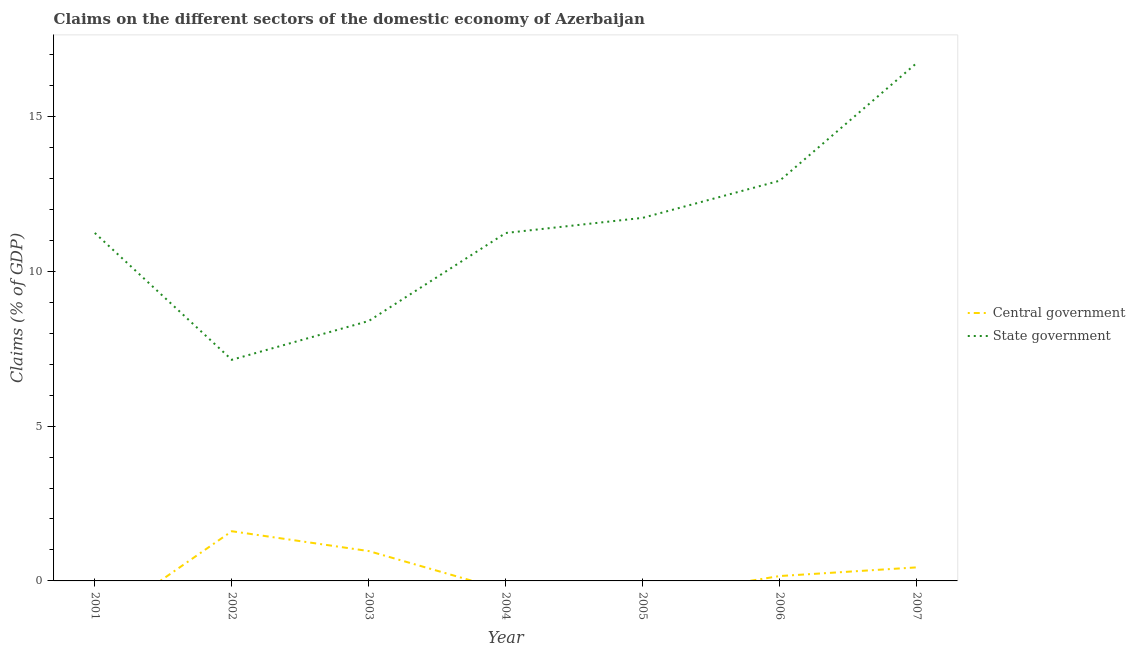How many different coloured lines are there?
Keep it short and to the point. 2. Is the number of lines equal to the number of legend labels?
Your answer should be compact. No. What is the claims on central government in 2001?
Your answer should be very brief. 0. Across all years, what is the maximum claims on state government?
Your answer should be very brief. 16.73. Across all years, what is the minimum claims on central government?
Keep it short and to the point. 0. In which year was the claims on central government maximum?
Give a very brief answer. 2002. What is the total claims on central government in the graph?
Offer a terse response. 3.16. What is the difference between the claims on state government in 2001 and that in 2007?
Ensure brevity in your answer.  -5.49. What is the difference between the claims on state government in 2004 and the claims on central government in 2001?
Your response must be concise. 11.24. What is the average claims on central government per year?
Ensure brevity in your answer.  0.45. In the year 2006, what is the difference between the claims on state government and claims on central government?
Offer a terse response. 12.77. What is the ratio of the claims on state government in 2004 to that in 2006?
Make the answer very short. 0.87. What is the difference between the highest and the second highest claims on state government?
Provide a short and direct response. 3.8. What is the difference between the highest and the lowest claims on central government?
Make the answer very short. 1.6. Is the sum of the claims on state government in 2005 and 2006 greater than the maximum claims on central government across all years?
Give a very brief answer. Yes. Does the claims on state government monotonically increase over the years?
Ensure brevity in your answer.  No. Is the claims on central government strictly less than the claims on state government over the years?
Provide a succinct answer. Yes. How many lines are there?
Provide a short and direct response. 2. What is the difference between two consecutive major ticks on the Y-axis?
Your answer should be very brief. 5. Are the values on the major ticks of Y-axis written in scientific E-notation?
Your answer should be very brief. No. Does the graph contain any zero values?
Provide a short and direct response. Yes. Does the graph contain grids?
Offer a terse response. No. Where does the legend appear in the graph?
Offer a very short reply. Center right. What is the title of the graph?
Give a very brief answer. Claims on the different sectors of the domestic economy of Azerbaijan. Does "Banks" appear as one of the legend labels in the graph?
Provide a succinct answer. No. What is the label or title of the X-axis?
Provide a short and direct response. Year. What is the label or title of the Y-axis?
Your answer should be very brief. Claims (% of GDP). What is the Claims (% of GDP) of Central government in 2001?
Provide a short and direct response. 0. What is the Claims (% of GDP) in State government in 2001?
Offer a terse response. 11.24. What is the Claims (% of GDP) of Central government in 2002?
Give a very brief answer. 1.6. What is the Claims (% of GDP) in State government in 2002?
Give a very brief answer. 7.14. What is the Claims (% of GDP) in Central government in 2003?
Your answer should be compact. 0.96. What is the Claims (% of GDP) in State government in 2003?
Keep it short and to the point. 8.4. What is the Claims (% of GDP) in Central government in 2004?
Your response must be concise. 0. What is the Claims (% of GDP) in State government in 2004?
Give a very brief answer. 11.24. What is the Claims (% of GDP) of State government in 2005?
Make the answer very short. 11.73. What is the Claims (% of GDP) in Central government in 2006?
Give a very brief answer. 0.16. What is the Claims (% of GDP) in State government in 2006?
Make the answer very short. 12.93. What is the Claims (% of GDP) of Central government in 2007?
Provide a succinct answer. 0.44. What is the Claims (% of GDP) of State government in 2007?
Give a very brief answer. 16.73. Across all years, what is the maximum Claims (% of GDP) in Central government?
Offer a very short reply. 1.6. Across all years, what is the maximum Claims (% of GDP) in State government?
Provide a succinct answer. 16.73. Across all years, what is the minimum Claims (% of GDP) in Central government?
Ensure brevity in your answer.  0. Across all years, what is the minimum Claims (% of GDP) of State government?
Your answer should be very brief. 7.14. What is the total Claims (% of GDP) in Central government in the graph?
Offer a very short reply. 3.16. What is the total Claims (% of GDP) in State government in the graph?
Your response must be concise. 79.39. What is the difference between the Claims (% of GDP) in State government in 2001 and that in 2002?
Provide a short and direct response. 4.1. What is the difference between the Claims (% of GDP) in State government in 2001 and that in 2003?
Make the answer very short. 2.84. What is the difference between the Claims (% of GDP) of State government in 2001 and that in 2004?
Provide a short and direct response. 0. What is the difference between the Claims (% of GDP) of State government in 2001 and that in 2005?
Provide a short and direct response. -0.49. What is the difference between the Claims (% of GDP) in State government in 2001 and that in 2006?
Provide a short and direct response. -1.69. What is the difference between the Claims (% of GDP) in State government in 2001 and that in 2007?
Offer a terse response. -5.49. What is the difference between the Claims (% of GDP) in Central government in 2002 and that in 2003?
Your response must be concise. 0.64. What is the difference between the Claims (% of GDP) in State government in 2002 and that in 2003?
Ensure brevity in your answer.  -1.25. What is the difference between the Claims (% of GDP) in State government in 2002 and that in 2004?
Make the answer very short. -4.1. What is the difference between the Claims (% of GDP) of State government in 2002 and that in 2005?
Keep it short and to the point. -4.58. What is the difference between the Claims (% of GDP) of Central government in 2002 and that in 2006?
Ensure brevity in your answer.  1.45. What is the difference between the Claims (% of GDP) in State government in 2002 and that in 2006?
Your answer should be very brief. -5.78. What is the difference between the Claims (% of GDP) in Central government in 2002 and that in 2007?
Keep it short and to the point. 1.17. What is the difference between the Claims (% of GDP) of State government in 2002 and that in 2007?
Give a very brief answer. -9.58. What is the difference between the Claims (% of GDP) in State government in 2003 and that in 2004?
Your answer should be very brief. -2.84. What is the difference between the Claims (% of GDP) of State government in 2003 and that in 2005?
Your answer should be very brief. -3.33. What is the difference between the Claims (% of GDP) of Central government in 2003 and that in 2006?
Offer a very short reply. 0.81. What is the difference between the Claims (% of GDP) in State government in 2003 and that in 2006?
Offer a very short reply. -4.53. What is the difference between the Claims (% of GDP) of Central government in 2003 and that in 2007?
Your answer should be compact. 0.53. What is the difference between the Claims (% of GDP) of State government in 2003 and that in 2007?
Ensure brevity in your answer.  -8.33. What is the difference between the Claims (% of GDP) of State government in 2004 and that in 2005?
Offer a terse response. -0.49. What is the difference between the Claims (% of GDP) of State government in 2004 and that in 2006?
Ensure brevity in your answer.  -1.69. What is the difference between the Claims (% of GDP) of State government in 2004 and that in 2007?
Your answer should be compact. -5.49. What is the difference between the Claims (% of GDP) of State government in 2005 and that in 2006?
Keep it short and to the point. -1.2. What is the difference between the Claims (% of GDP) of State government in 2005 and that in 2007?
Offer a terse response. -5. What is the difference between the Claims (% of GDP) of Central government in 2006 and that in 2007?
Provide a succinct answer. -0.28. What is the difference between the Claims (% of GDP) of State government in 2006 and that in 2007?
Give a very brief answer. -3.8. What is the difference between the Claims (% of GDP) in Central government in 2002 and the Claims (% of GDP) in State government in 2003?
Your answer should be very brief. -6.79. What is the difference between the Claims (% of GDP) in Central government in 2002 and the Claims (% of GDP) in State government in 2004?
Give a very brief answer. -9.63. What is the difference between the Claims (% of GDP) in Central government in 2002 and the Claims (% of GDP) in State government in 2005?
Make the answer very short. -10.12. What is the difference between the Claims (% of GDP) in Central government in 2002 and the Claims (% of GDP) in State government in 2006?
Offer a very short reply. -11.32. What is the difference between the Claims (% of GDP) of Central government in 2002 and the Claims (% of GDP) of State government in 2007?
Ensure brevity in your answer.  -15.12. What is the difference between the Claims (% of GDP) in Central government in 2003 and the Claims (% of GDP) in State government in 2004?
Keep it short and to the point. -10.27. What is the difference between the Claims (% of GDP) of Central government in 2003 and the Claims (% of GDP) of State government in 2005?
Your response must be concise. -10.76. What is the difference between the Claims (% of GDP) in Central government in 2003 and the Claims (% of GDP) in State government in 2006?
Provide a succinct answer. -11.96. What is the difference between the Claims (% of GDP) in Central government in 2003 and the Claims (% of GDP) in State government in 2007?
Your answer should be compact. -15.76. What is the difference between the Claims (% of GDP) in Central government in 2006 and the Claims (% of GDP) in State government in 2007?
Ensure brevity in your answer.  -16.57. What is the average Claims (% of GDP) of Central government per year?
Ensure brevity in your answer.  0.45. What is the average Claims (% of GDP) of State government per year?
Your answer should be very brief. 11.34. In the year 2002, what is the difference between the Claims (% of GDP) in Central government and Claims (% of GDP) in State government?
Your response must be concise. -5.54. In the year 2003, what is the difference between the Claims (% of GDP) in Central government and Claims (% of GDP) in State government?
Provide a succinct answer. -7.43. In the year 2006, what is the difference between the Claims (% of GDP) of Central government and Claims (% of GDP) of State government?
Ensure brevity in your answer.  -12.77. In the year 2007, what is the difference between the Claims (% of GDP) in Central government and Claims (% of GDP) in State government?
Make the answer very short. -16.29. What is the ratio of the Claims (% of GDP) of State government in 2001 to that in 2002?
Make the answer very short. 1.57. What is the ratio of the Claims (% of GDP) of State government in 2001 to that in 2003?
Provide a short and direct response. 1.34. What is the ratio of the Claims (% of GDP) in State government in 2001 to that in 2005?
Your response must be concise. 0.96. What is the ratio of the Claims (% of GDP) in State government in 2001 to that in 2006?
Ensure brevity in your answer.  0.87. What is the ratio of the Claims (% of GDP) in State government in 2001 to that in 2007?
Your answer should be very brief. 0.67. What is the ratio of the Claims (% of GDP) in Central government in 2002 to that in 2003?
Provide a short and direct response. 1.66. What is the ratio of the Claims (% of GDP) in State government in 2002 to that in 2003?
Your answer should be compact. 0.85. What is the ratio of the Claims (% of GDP) of State government in 2002 to that in 2004?
Your answer should be compact. 0.64. What is the ratio of the Claims (% of GDP) in State government in 2002 to that in 2005?
Ensure brevity in your answer.  0.61. What is the ratio of the Claims (% of GDP) in Central government in 2002 to that in 2006?
Your answer should be compact. 10.18. What is the ratio of the Claims (% of GDP) of State government in 2002 to that in 2006?
Keep it short and to the point. 0.55. What is the ratio of the Claims (% of GDP) of Central government in 2002 to that in 2007?
Provide a succinct answer. 3.67. What is the ratio of the Claims (% of GDP) of State government in 2002 to that in 2007?
Your answer should be very brief. 0.43. What is the ratio of the Claims (% of GDP) of State government in 2003 to that in 2004?
Your answer should be very brief. 0.75. What is the ratio of the Claims (% of GDP) of State government in 2003 to that in 2005?
Provide a succinct answer. 0.72. What is the ratio of the Claims (% of GDP) of Central government in 2003 to that in 2006?
Provide a short and direct response. 6.12. What is the ratio of the Claims (% of GDP) of State government in 2003 to that in 2006?
Your response must be concise. 0.65. What is the ratio of the Claims (% of GDP) in Central government in 2003 to that in 2007?
Keep it short and to the point. 2.2. What is the ratio of the Claims (% of GDP) of State government in 2003 to that in 2007?
Offer a very short reply. 0.5. What is the ratio of the Claims (% of GDP) in State government in 2004 to that in 2006?
Your response must be concise. 0.87. What is the ratio of the Claims (% of GDP) of State government in 2004 to that in 2007?
Make the answer very short. 0.67. What is the ratio of the Claims (% of GDP) of State government in 2005 to that in 2006?
Your answer should be compact. 0.91. What is the ratio of the Claims (% of GDP) of State government in 2005 to that in 2007?
Offer a terse response. 0.7. What is the ratio of the Claims (% of GDP) in Central government in 2006 to that in 2007?
Provide a short and direct response. 0.36. What is the ratio of the Claims (% of GDP) of State government in 2006 to that in 2007?
Offer a very short reply. 0.77. What is the difference between the highest and the second highest Claims (% of GDP) in Central government?
Offer a terse response. 0.64. What is the difference between the highest and the second highest Claims (% of GDP) of State government?
Provide a succinct answer. 3.8. What is the difference between the highest and the lowest Claims (% of GDP) in Central government?
Your response must be concise. 1.6. What is the difference between the highest and the lowest Claims (% of GDP) of State government?
Provide a succinct answer. 9.58. 